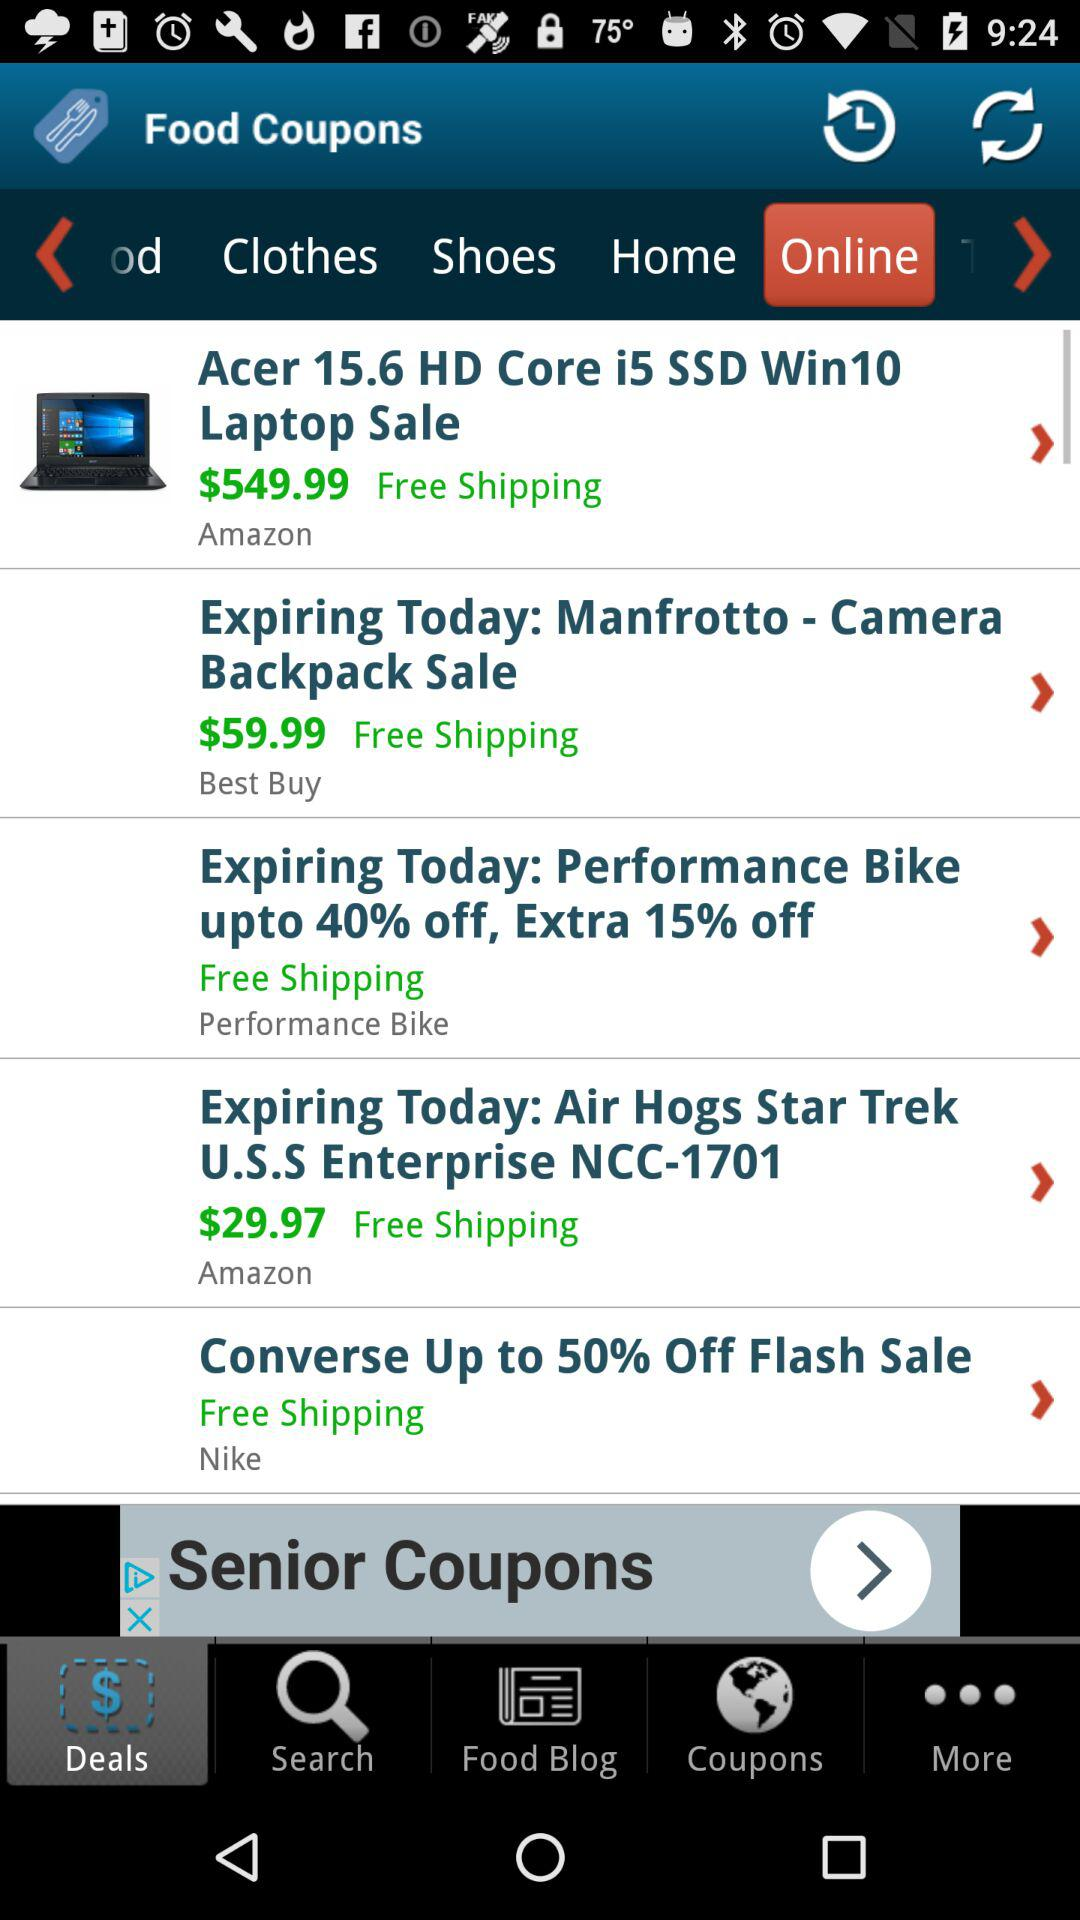Is laptop delivery free? Laptop delivery is free. 